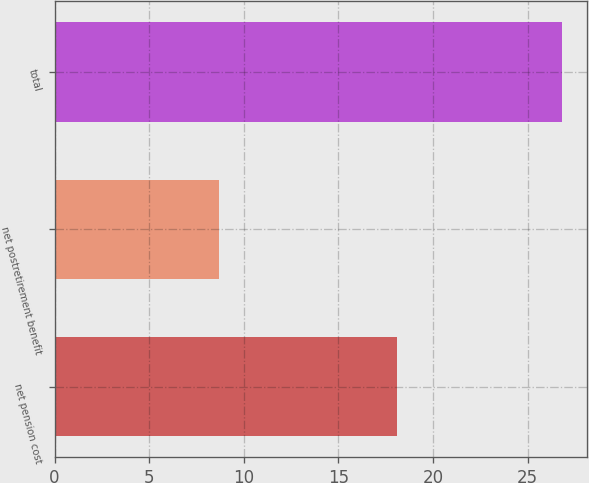Convert chart to OTSL. <chart><loc_0><loc_0><loc_500><loc_500><bar_chart><fcel>net pension cost<fcel>net postretirement benefit<fcel>total<nl><fcel>18.1<fcel>8.7<fcel>26.8<nl></chart> 